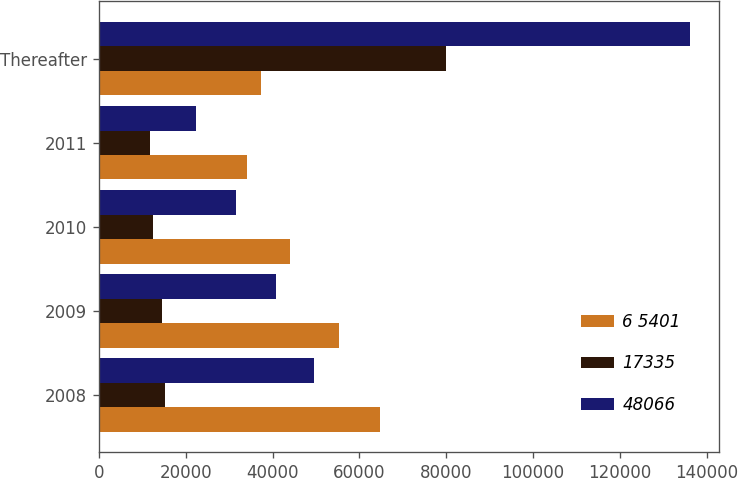Convert chart to OTSL. <chart><loc_0><loc_0><loc_500><loc_500><stacked_bar_chart><ecel><fcel>2008<fcel>2009<fcel>2010<fcel>2011<fcel>Thereafter<nl><fcel>6 5401<fcel>64810<fcel>55336<fcel>44053<fcel>34166<fcel>37428<nl><fcel>17335<fcel>15257<fcel>14646<fcel>12468<fcel>11775<fcel>79847<nl><fcel>48066<fcel>49553<fcel>40690<fcel>31585<fcel>22391<fcel>135999<nl></chart> 